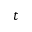<formula> <loc_0><loc_0><loc_500><loc_500>t</formula> 